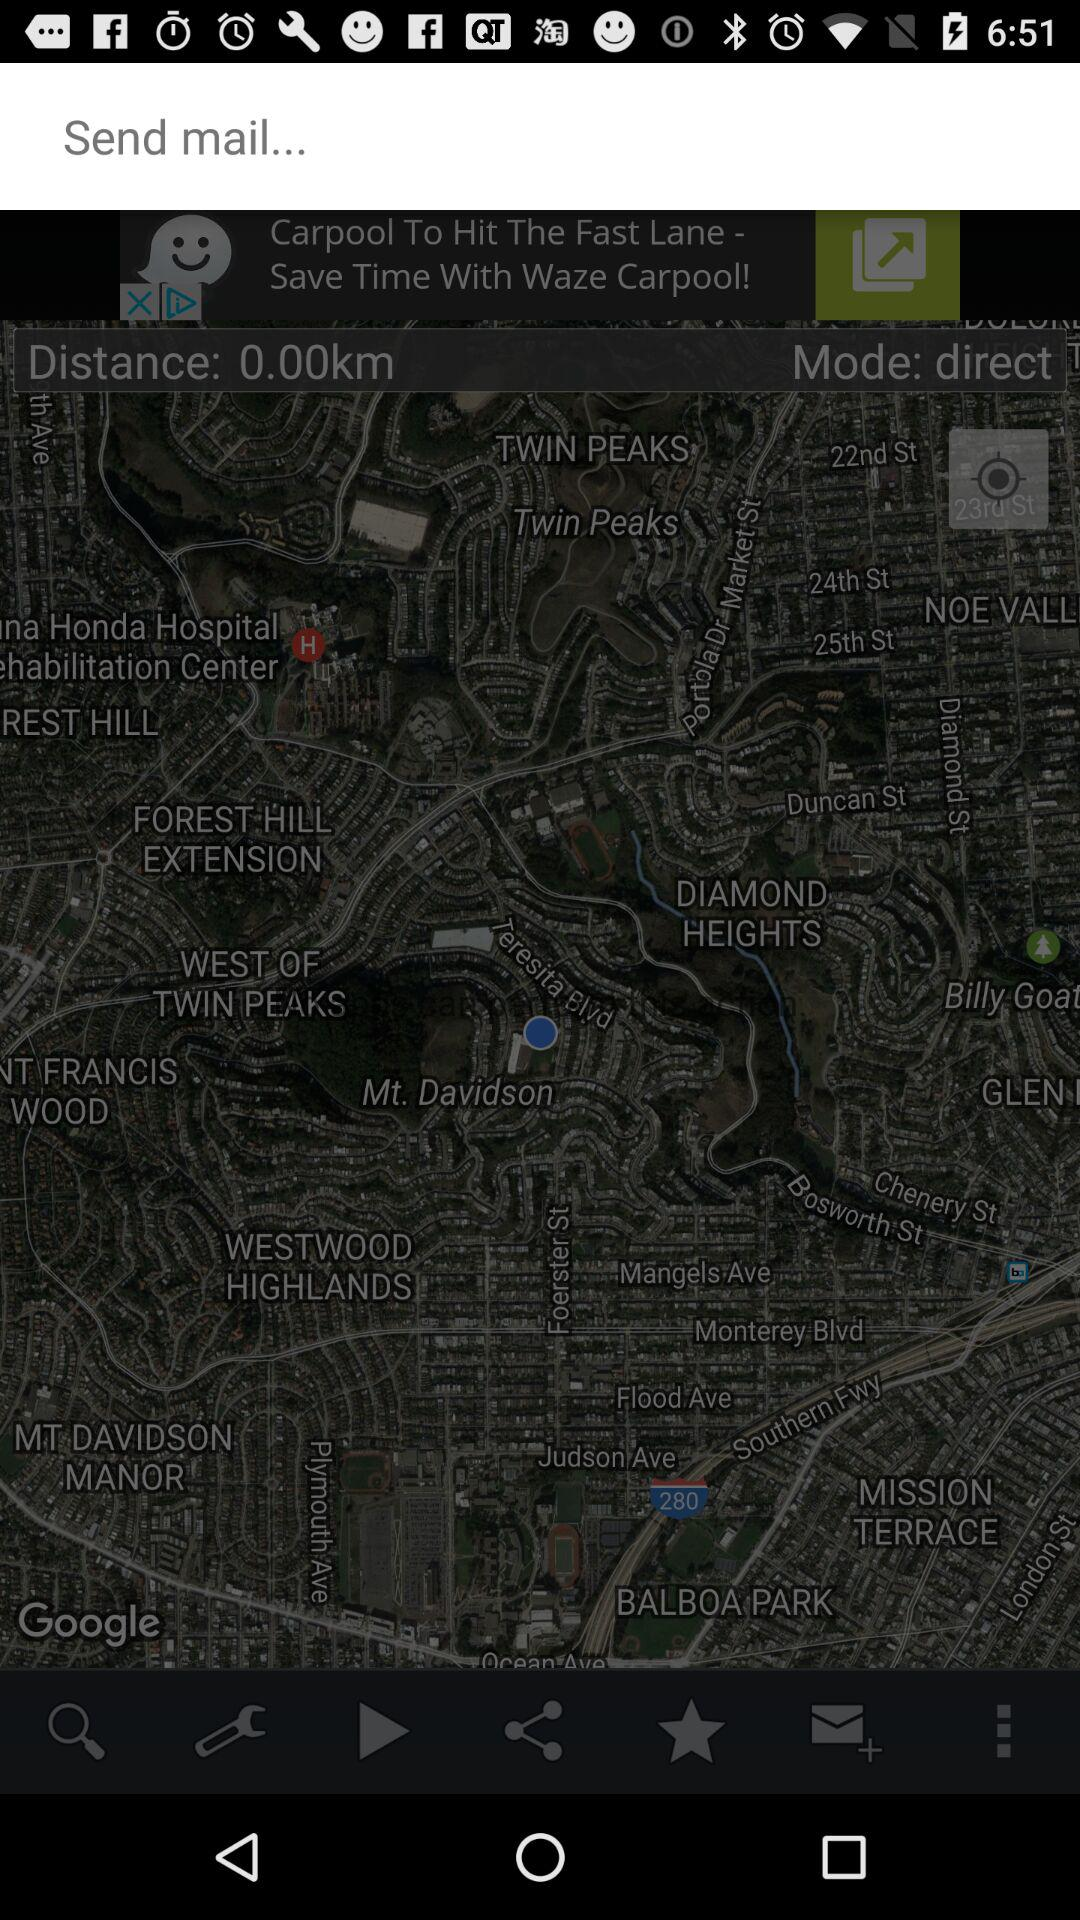What is the distance? The distance is 0.00 km. 